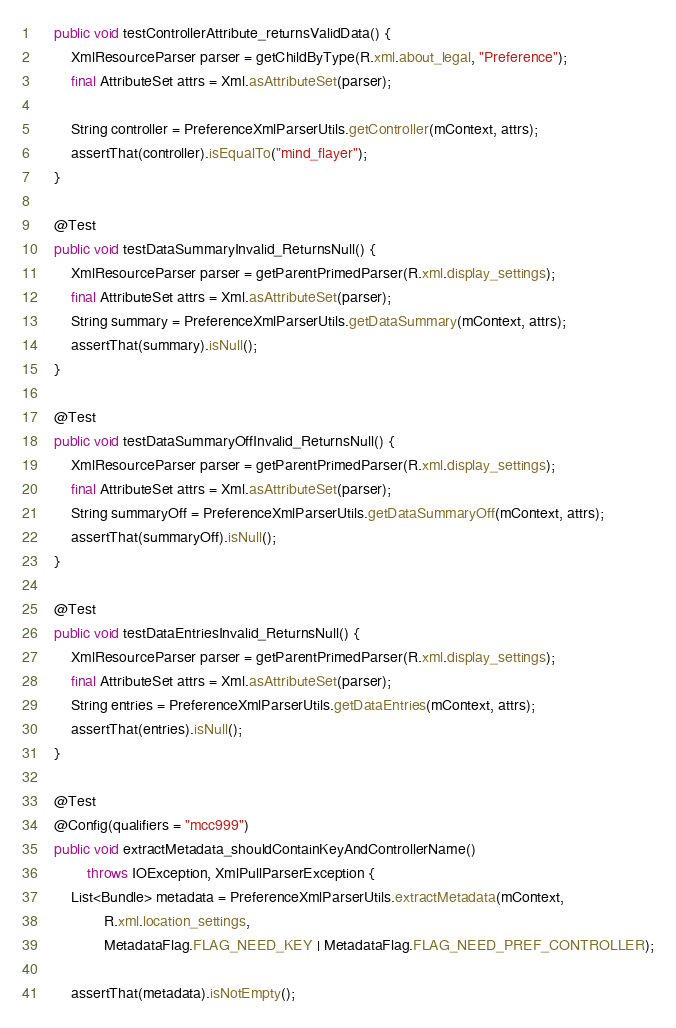Convert code to text. <code><loc_0><loc_0><loc_500><loc_500><_Java_>    public void testControllerAttribute_returnsValidData() {
        XmlResourceParser parser = getChildByType(R.xml.about_legal, "Preference");
        final AttributeSet attrs = Xml.asAttributeSet(parser);

        String controller = PreferenceXmlParserUtils.getController(mContext, attrs);
        assertThat(controller).isEqualTo("mind_flayer");
    }

    @Test
    public void testDataSummaryInvalid_ReturnsNull() {
        XmlResourceParser parser = getParentPrimedParser(R.xml.display_settings);
        final AttributeSet attrs = Xml.asAttributeSet(parser);
        String summary = PreferenceXmlParserUtils.getDataSummary(mContext, attrs);
        assertThat(summary).isNull();
    }

    @Test
    public void testDataSummaryOffInvalid_ReturnsNull() {
        XmlResourceParser parser = getParentPrimedParser(R.xml.display_settings);
        final AttributeSet attrs = Xml.asAttributeSet(parser);
        String summaryOff = PreferenceXmlParserUtils.getDataSummaryOff(mContext, attrs);
        assertThat(summaryOff).isNull();
    }

    @Test
    public void testDataEntriesInvalid_ReturnsNull() {
        XmlResourceParser parser = getParentPrimedParser(R.xml.display_settings);
        final AttributeSet attrs = Xml.asAttributeSet(parser);
        String entries = PreferenceXmlParserUtils.getDataEntries(mContext, attrs);
        assertThat(entries).isNull();
    }

    @Test
    @Config(qualifiers = "mcc999")
    public void extractMetadata_shouldContainKeyAndControllerName()
            throws IOException, XmlPullParserException {
        List<Bundle> metadata = PreferenceXmlParserUtils.extractMetadata(mContext,
                R.xml.location_settings,
                MetadataFlag.FLAG_NEED_KEY | MetadataFlag.FLAG_NEED_PREF_CONTROLLER);

        assertThat(metadata).isNotEmpty();</code> 